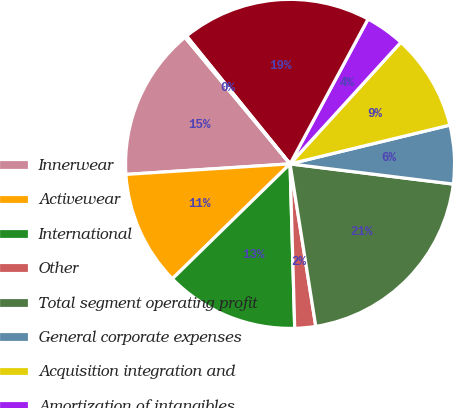<chart> <loc_0><loc_0><loc_500><loc_500><pie_chart><fcel>Innerwear<fcel>Activewear<fcel>International<fcel>Other<fcel>Total segment operating profit<fcel>General corporate expenses<fcel>Acquisition integration and<fcel>Amortization of intangibles<fcel>Total operating profit<fcel>Other expenses<nl><fcel>14.99%<fcel>11.29%<fcel>13.14%<fcel>2.05%<fcel>20.54%<fcel>5.75%<fcel>9.45%<fcel>3.9%<fcel>18.69%<fcel>0.2%<nl></chart> 